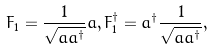<formula> <loc_0><loc_0><loc_500><loc_500>F _ { 1 } = \frac { 1 } { \sqrt { a a ^ { \dagger } } } a , F _ { 1 } ^ { \dagger } = a ^ { \dagger } \frac { 1 } { \sqrt { a a ^ { \dagger } } } ,</formula> 